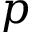Convert formula to latex. <formula><loc_0><loc_0><loc_500><loc_500>p</formula> 